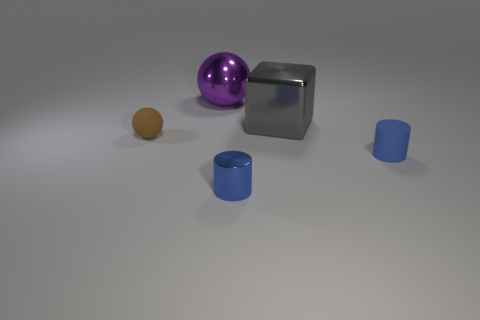Is the color of the small metallic thing the same as the rubber cylinder?
Give a very brief answer. Yes. What number of blue cylinders have the same material as the purple ball?
Make the answer very short. 1. There is a thing right of the large gray object; what is its shape?
Give a very brief answer. Cylinder. Is the tiny cylinder that is in front of the matte cylinder made of the same material as the ball that is to the right of the tiny brown sphere?
Your answer should be very brief. Yes. Is there a large shiny thing of the same shape as the tiny brown matte thing?
Provide a short and direct response. Yes. How many things are either small blue objects to the left of the cube or cubes?
Give a very brief answer. 2. Is the number of matte cylinders that are right of the matte cylinder greater than the number of brown objects that are right of the small brown thing?
Offer a terse response. No. How many shiny things are big gray objects or yellow cylinders?
Your answer should be very brief. 1. There is another tiny cylinder that is the same color as the matte cylinder; what is it made of?
Offer a very short reply. Metal. Are there fewer blue matte cylinders behind the big gray block than rubber things that are to the right of the tiny rubber sphere?
Offer a very short reply. Yes. 